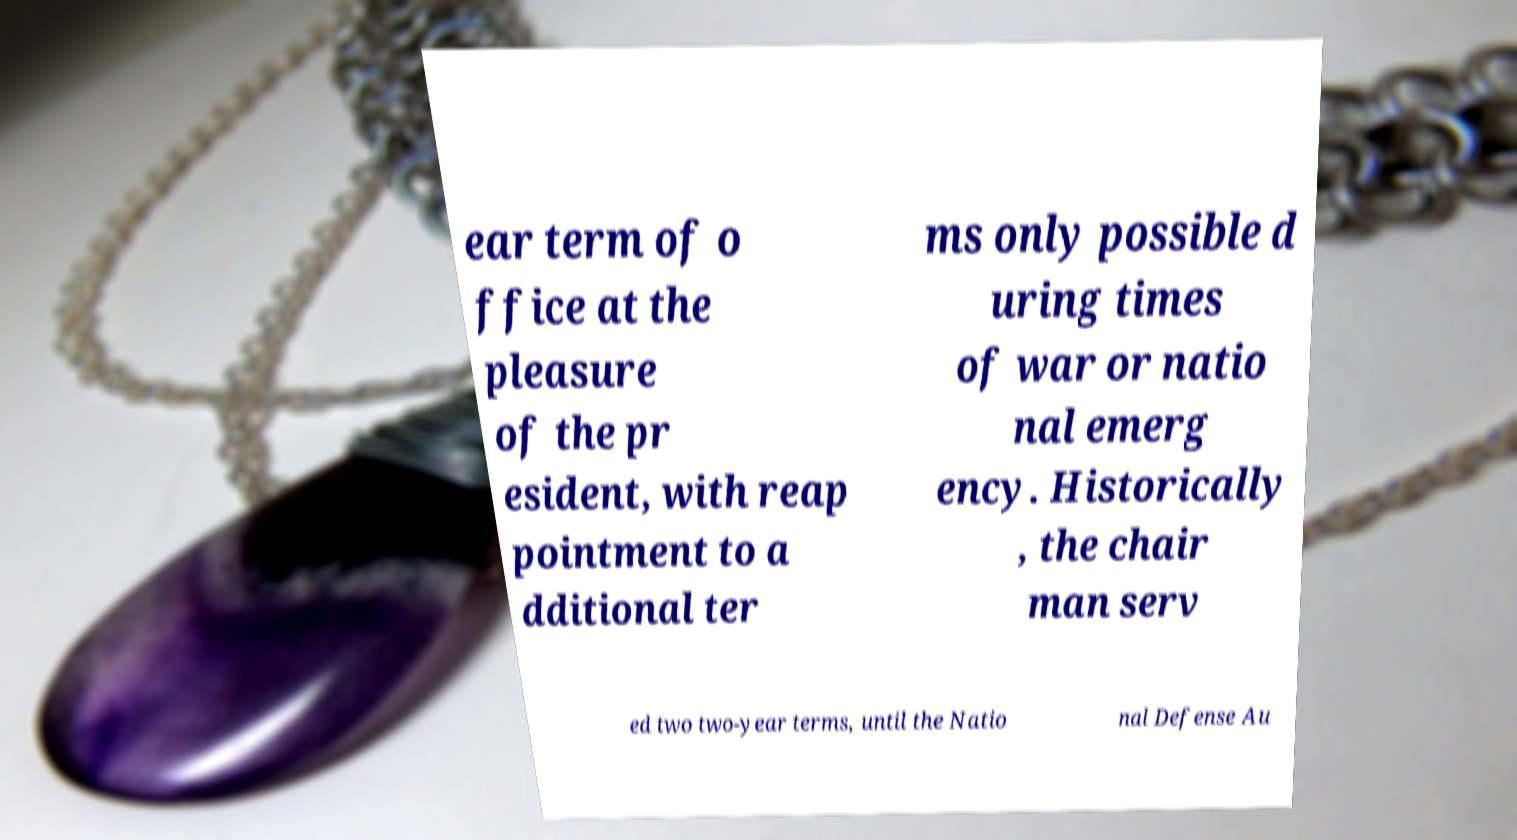Please identify and transcribe the text found in this image. ear term of o ffice at the pleasure of the pr esident, with reap pointment to a dditional ter ms only possible d uring times of war or natio nal emerg ency. Historically , the chair man serv ed two two-year terms, until the Natio nal Defense Au 